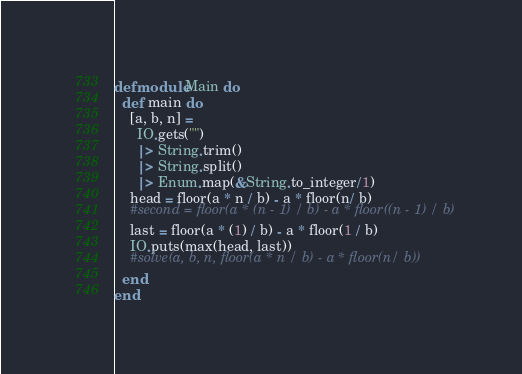Convert code to text. <code><loc_0><loc_0><loc_500><loc_500><_Elixir_>defmodule Main do
  def main do
    [a, b, n] =
      IO.gets("")
      |> String.trim()
      |> String.split()
      |> Enum.map(&String.to_integer/1)
    head = floor(a * n / b) - a * floor(n/ b)
    #second = floor(a * (n - 1) / b) - a * floor((n - 1) / b)
    last = floor(a * (1) / b) - a * floor(1 / b)
	IO.puts(max(head, last))
    #solve(a, b, n, floor(a * n / b) - a * floor(n/ b))
  end
end</code> 